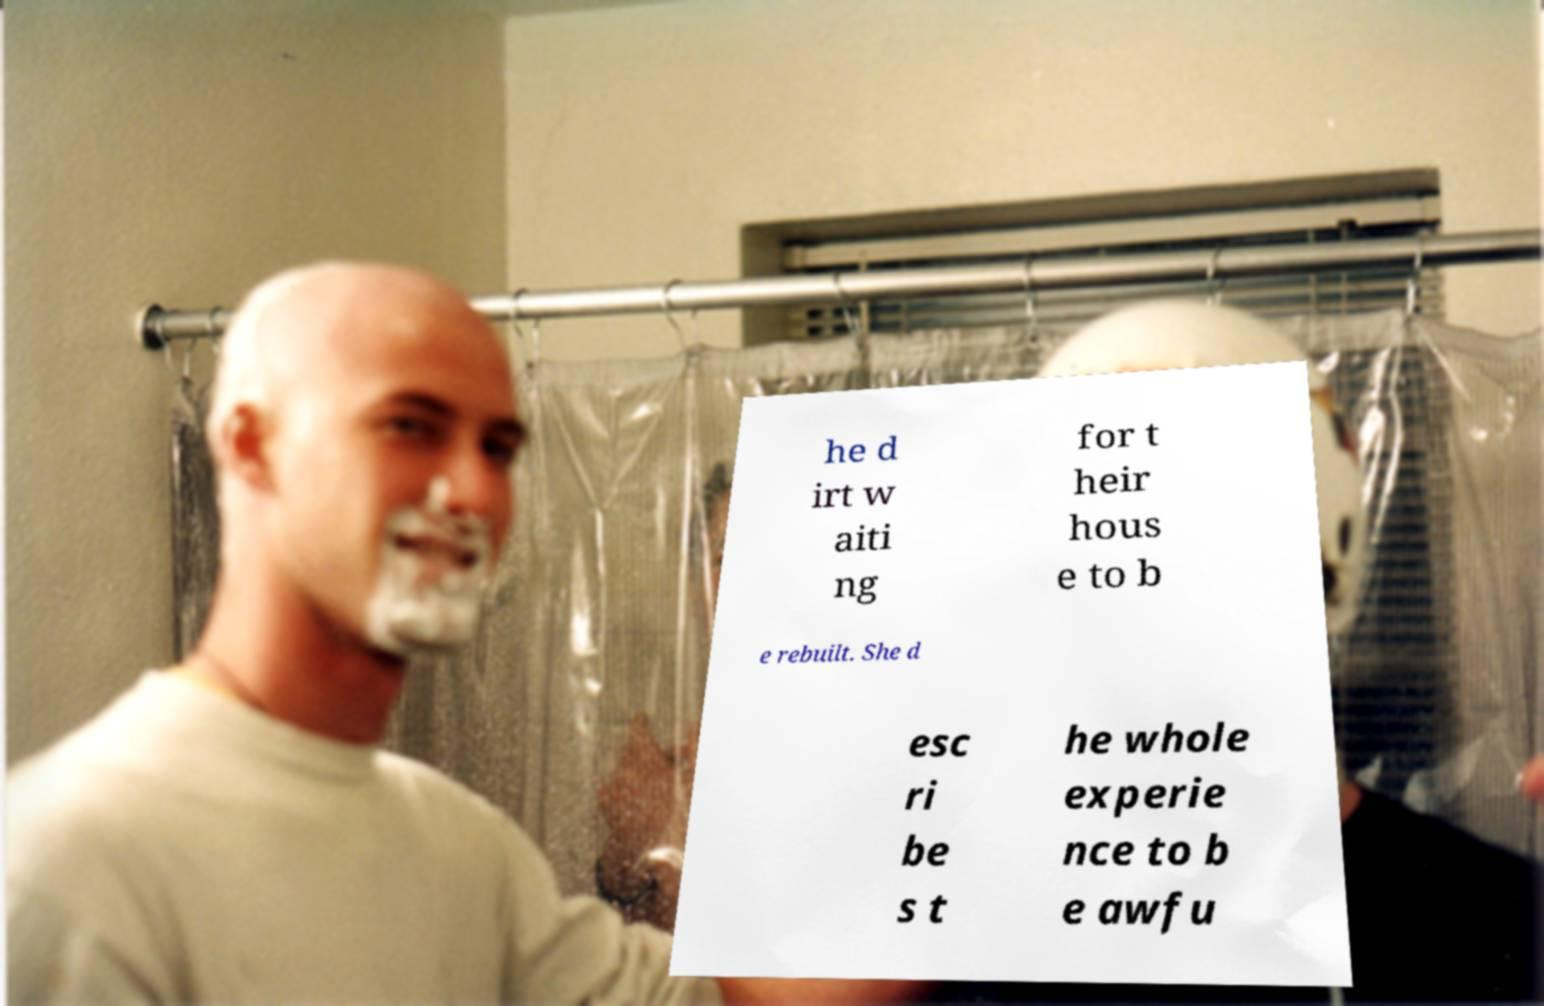What messages or text are displayed in this image? I need them in a readable, typed format. he d irt w aiti ng for t heir hous e to b e rebuilt. She d esc ri be s t he whole experie nce to b e awfu 